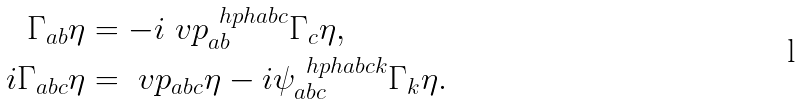<formula> <loc_0><loc_0><loc_500><loc_500>\Gamma _ { a b } \eta & = - i \ v p _ { a b } ^ { \ h p h { a b } c } \Gamma _ { c } \eta , \\ i \Gamma _ { a b c } \eta & = \ v p _ { a b c } \eta - i \psi _ { a b c } ^ { \ h p h { a b c } k } \Gamma _ { k } \eta .</formula> 